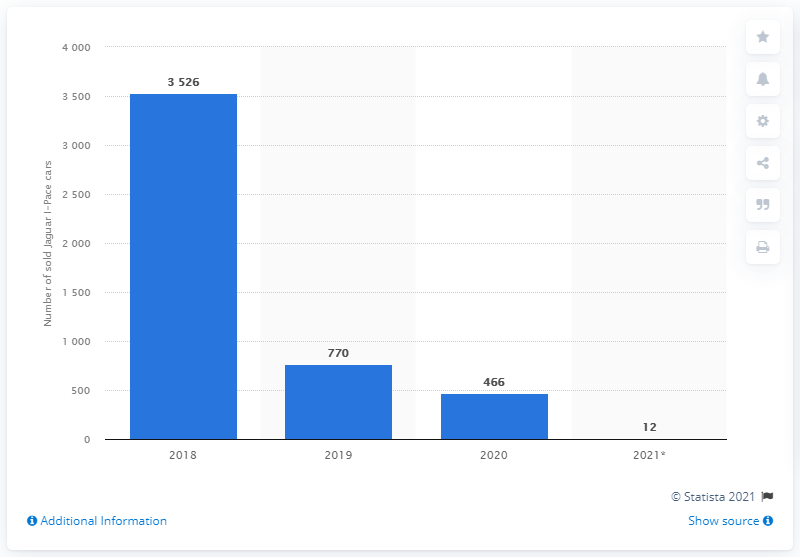Indicate a few pertinent items in this graphic. The Jaguar I-Pace outperformed the Tesla Model S and Model X in 2020. As of May 2021, a total of 12 Jaguar I-Pace cars were sold in the Netherlands. 